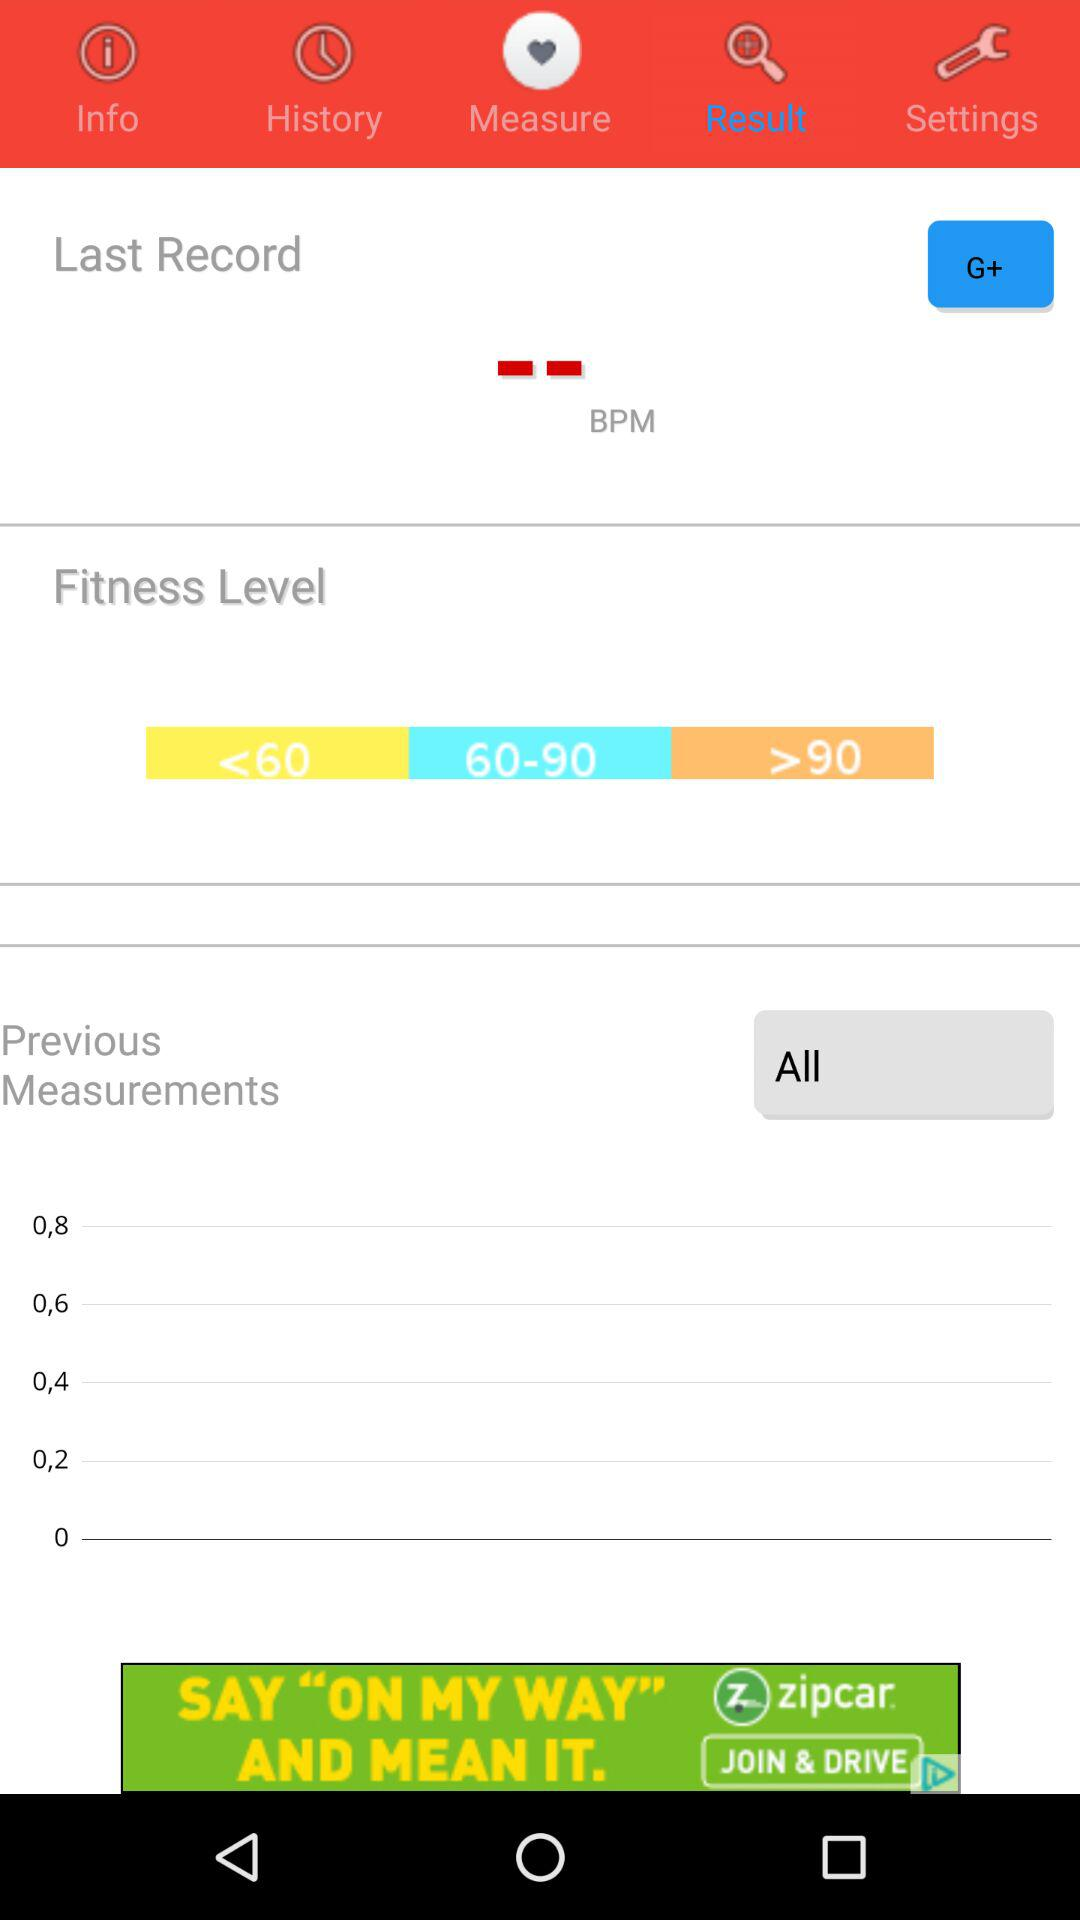Which option is selected? The selected options are "Result" and "All". 